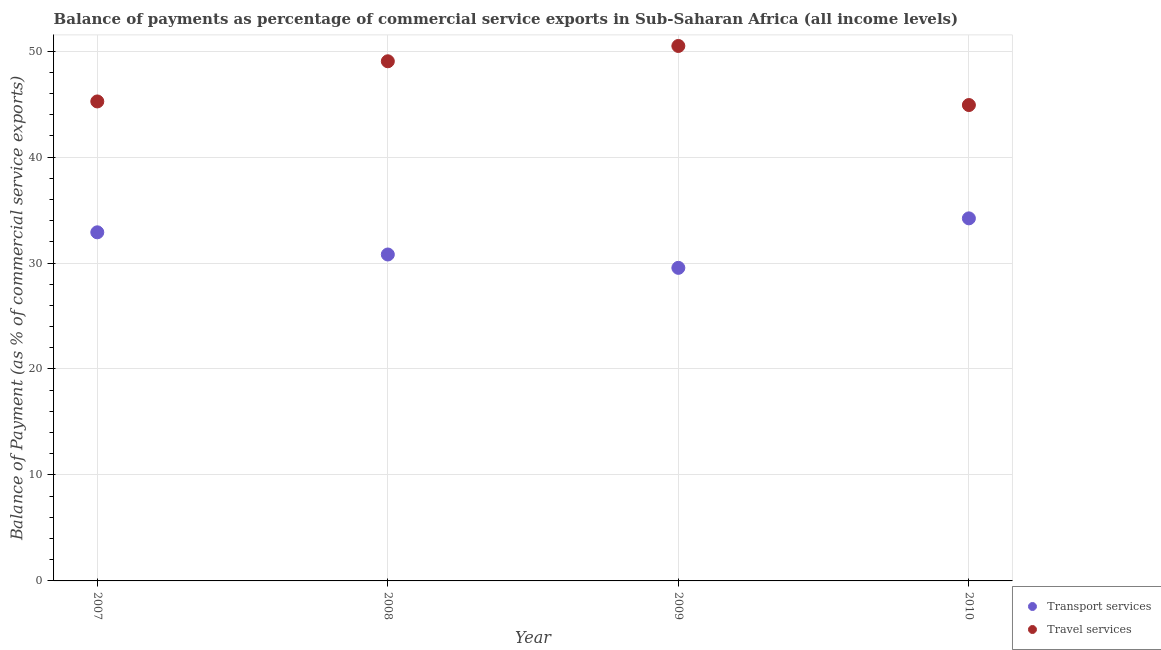How many different coloured dotlines are there?
Offer a terse response. 2. What is the balance of payments of transport services in 2010?
Ensure brevity in your answer.  34.21. Across all years, what is the maximum balance of payments of transport services?
Ensure brevity in your answer.  34.21. Across all years, what is the minimum balance of payments of transport services?
Keep it short and to the point. 29.54. In which year was the balance of payments of travel services maximum?
Provide a short and direct response. 2009. What is the total balance of payments of travel services in the graph?
Your response must be concise. 189.67. What is the difference between the balance of payments of travel services in 2008 and that in 2010?
Your answer should be very brief. 4.13. What is the difference between the balance of payments of travel services in 2008 and the balance of payments of transport services in 2009?
Ensure brevity in your answer.  19.49. What is the average balance of payments of transport services per year?
Your answer should be very brief. 31.86. In the year 2007, what is the difference between the balance of payments of transport services and balance of payments of travel services?
Offer a very short reply. -12.35. What is the ratio of the balance of payments of travel services in 2007 to that in 2008?
Provide a short and direct response. 0.92. Is the difference between the balance of payments of travel services in 2007 and 2010 greater than the difference between the balance of payments of transport services in 2007 and 2010?
Offer a terse response. Yes. What is the difference between the highest and the second highest balance of payments of travel services?
Make the answer very short. 1.44. What is the difference between the highest and the lowest balance of payments of transport services?
Provide a succinct answer. 4.67. Is the sum of the balance of payments of transport services in 2007 and 2009 greater than the maximum balance of payments of travel services across all years?
Keep it short and to the point. Yes. Is the balance of payments of travel services strictly greater than the balance of payments of transport services over the years?
Your response must be concise. Yes. Is the balance of payments of transport services strictly less than the balance of payments of travel services over the years?
Offer a very short reply. Yes. How many years are there in the graph?
Give a very brief answer. 4. Does the graph contain grids?
Your answer should be very brief. Yes. How many legend labels are there?
Your answer should be compact. 2. What is the title of the graph?
Provide a short and direct response. Balance of payments as percentage of commercial service exports in Sub-Saharan Africa (all income levels). Does "Investment in Telecom" appear as one of the legend labels in the graph?
Your answer should be compact. No. What is the label or title of the X-axis?
Offer a very short reply. Year. What is the label or title of the Y-axis?
Offer a terse response. Balance of Payment (as % of commercial service exports). What is the Balance of Payment (as % of commercial service exports) in Transport services in 2007?
Offer a very short reply. 32.9. What is the Balance of Payment (as % of commercial service exports) of Travel services in 2007?
Keep it short and to the point. 45.25. What is the Balance of Payment (as % of commercial service exports) of Transport services in 2008?
Provide a succinct answer. 30.8. What is the Balance of Payment (as % of commercial service exports) of Travel services in 2008?
Your answer should be very brief. 49.04. What is the Balance of Payment (as % of commercial service exports) of Transport services in 2009?
Provide a succinct answer. 29.54. What is the Balance of Payment (as % of commercial service exports) in Travel services in 2009?
Keep it short and to the point. 50.48. What is the Balance of Payment (as % of commercial service exports) in Transport services in 2010?
Your answer should be compact. 34.21. What is the Balance of Payment (as % of commercial service exports) of Travel services in 2010?
Provide a succinct answer. 44.91. Across all years, what is the maximum Balance of Payment (as % of commercial service exports) in Transport services?
Your response must be concise. 34.21. Across all years, what is the maximum Balance of Payment (as % of commercial service exports) of Travel services?
Make the answer very short. 50.48. Across all years, what is the minimum Balance of Payment (as % of commercial service exports) of Transport services?
Your response must be concise. 29.54. Across all years, what is the minimum Balance of Payment (as % of commercial service exports) in Travel services?
Give a very brief answer. 44.91. What is the total Balance of Payment (as % of commercial service exports) of Transport services in the graph?
Your answer should be compact. 127.46. What is the total Balance of Payment (as % of commercial service exports) of Travel services in the graph?
Give a very brief answer. 189.67. What is the difference between the Balance of Payment (as % of commercial service exports) of Transport services in 2007 and that in 2008?
Provide a succinct answer. 2.09. What is the difference between the Balance of Payment (as % of commercial service exports) of Travel services in 2007 and that in 2008?
Offer a terse response. -3.79. What is the difference between the Balance of Payment (as % of commercial service exports) in Transport services in 2007 and that in 2009?
Provide a short and direct response. 3.35. What is the difference between the Balance of Payment (as % of commercial service exports) of Travel services in 2007 and that in 2009?
Offer a terse response. -5.23. What is the difference between the Balance of Payment (as % of commercial service exports) in Transport services in 2007 and that in 2010?
Your answer should be very brief. -1.32. What is the difference between the Balance of Payment (as % of commercial service exports) of Travel services in 2007 and that in 2010?
Your answer should be very brief. 0.34. What is the difference between the Balance of Payment (as % of commercial service exports) of Transport services in 2008 and that in 2009?
Keep it short and to the point. 1.26. What is the difference between the Balance of Payment (as % of commercial service exports) in Travel services in 2008 and that in 2009?
Make the answer very short. -1.44. What is the difference between the Balance of Payment (as % of commercial service exports) in Transport services in 2008 and that in 2010?
Provide a short and direct response. -3.41. What is the difference between the Balance of Payment (as % of commercial service exports) of Travel services in 2008 and that in 2010?
Your answer should be compact. 4.13. What is the difference between the Balance of Payment (as % of commercial service exports) in Transport services in 2009 and that in 2010?
Offer a very short reply. -4.67. What is the difference between the Balance of Payment (as % of commercial service exports) of Travel services in 2009 and that in 2010?
Give a very brief answer. 5.57. What is the difference between the Balance of Payment (as % of commercial service exports) of Transport services in 2007 and the Balance of Payment (as % of commercial service exports) of Travel services in 2008?
Make the answer very short. -16.14. What is the difference between the Balance of Payment (as % of commercial service exports) in Transport services in 2007 and the Balance of Payment (as % of commercial service exports) in Travel services in 2009?
Give a very brief answer. -17.58. What is the difference between the Balance of Payment (as % of commercial service exports) in Transport services in 2007 and the Balance of Payment (as % of commercial service exports) in Travel services in 2010?
Give a very brief answer. -12.01. What is the difference between the Balance of Payment (as % of commercial service exports) of Transport services in 2008 and the Balance of Payment (as % of commercial service exports) of Travel services in 2009?
Make the answer very short. -19.68. What is the difference between the Balance of Payment (as % of commercial service exports) of Transport services in 2008 and the Balance of Payment (as % of commercial service exports) of Travel services in 2010?
Provide a succinct answer. -14.1. What is the difference between the Balance of Payment (as % of commercial service exports) of Transport services in 2009 and the Balance of Payment (as % of commercial service exports) of Travel services in 2010?
Keep it short and to the point. -15.36. What is the average Balance of Payment (as % of commercial service exports) in Transport services per year?
Your answer should be very brief. 31.86. What is the average Balance of Payment (as % of commercial service exports) in Travel services per year?
Provide a succinct answer. 47.42. In the year 2007, what is the difference between the Balance of Payment (as % of commercial service exports) in Transport services and Balance of Payment (as % of commercial service exports) in Travel services?
Make the answer very short. -12.35. In the year 2008, what is the difference between the Balance of Payment (as % of commercial service exports) of Transport services and Balance of Payment (as % of commercial service exports) of Travel services?
Offer a terse response. -18.23. In the year 2009, what is the difference between the Balance of Payment (as % of commercial service exports) in Transport services and Balance of Payment (as % of commercial service exports) in Travel services?
Provide a succinct answer. -20.94. In the year 2010, what is the difference between the Balance of Payment (as % of commercial service exports) of Transport services and Balance of Payment (as % of commercial service exports) of Travel services?
Provide a short and direct response. -10.69. What is the ratio of the Balance of Payment (as % of commercial service exports) in Transport services in 2007 to that in 2008?
Provide a succinct answer. 1.07. What is the ratio of the Balance of Payment (as % of commercial service exports) in Travel services in 2007 to that in 2008?
Your response must be concise. 0.92. What is the ratio of the Balance of Payment (as % of commercial service exports) in Transport services in 2007 to that in 2009?
Keep it short and to the point. 1.11. What is the ratio of the Balance of Payment (as % of commercial service exports) of Travel services in 2007 to that in 2009?
Your answer should be very brief. 0.9. What is the ratio of the Balance of Payment (as % of commercial service exports) of Transport services in 2007 to that in 2010?
Offer a terse response. 0.96. What is the ratio of the Balance of Payment (as % of commercial service exports) of Travel services in 2007 to that in 2010?
Provide a short and direct response. 1.01. What is the ratio of the Balance of Payment (as % of commercial service exports) of Transport services in 2008 to that in 2009?
Your answer should be compact. 1.04. What is the ratio of the Balance of Payment (as % of commercial service exports) of Travel services in 2008 to that in 2009?
Offer a very short reply. 0.97. What is the ratio of the Balance of Payment (as % of commercial service exports) of Transport services in 2008 to that in 2010?
Your answer should be compact. 0.9. What is the ratio of the Balance of Payment (as % of commercial service exports) of Travel services in 2008 to that in 2010?
Your answer should be very brief. 1.09. What is the ratio of the Balance of Payment (as % of commercial service exports) in Transport services in 2009 to that in 2010?
Provide a short and direct response. 0.86. What is the ratio of the Balance of Payment (as % of commercial service exports) in Travel services in 2009 to that in 2010?
Provide a succinct answer. 1.12. What is the difference between the highest and the second highest Balance of Payment (as % of commercial service exports) in Transport services?
Provide a succinct answer. 1.32. What is the difference between the highest and the second highest Balance of Payment (as % of commercial service exports) of Travel services?
Make the answer very short. 1.44. What is the difference between the highest and the lowest Balance of Payment (as % of commercial service exports) in Transport services?
Make the answer very short. 4.67. What is the difference between the highest and the lowest Balance of Payment (as % of commercial service exports) of Travel services?
Provide a succinct answer. 5.57. 